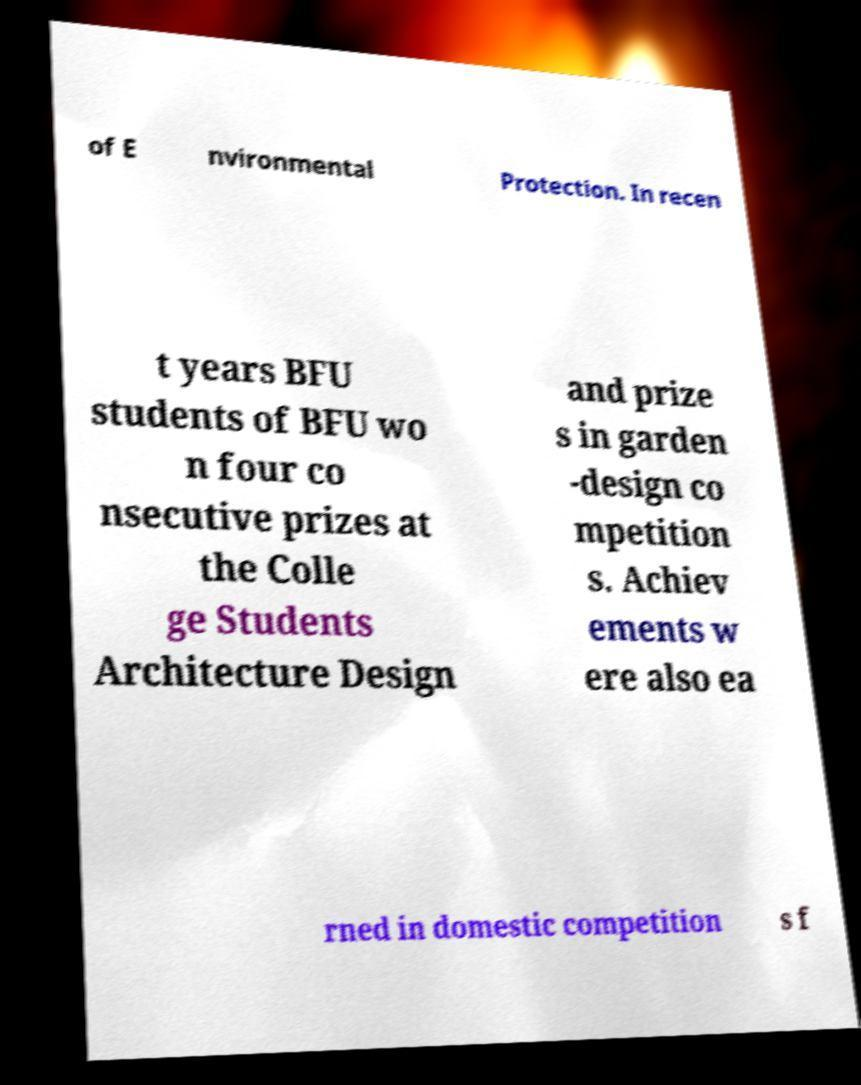Please read and relay the text visible in this image. What does it say? of E nvironmental Protection. In recen t years BFU students of BFU wo n four co nsecutive prizes at the Colle ge Students Architecture Design and prize s in garden -design co mpetition s. Achiev ements w ere also ea rned in domestic competition s f 